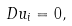<formula> <loc_0><loc_0><loc_500><loc_500>D u _ { i } = 0 ,</formula> 